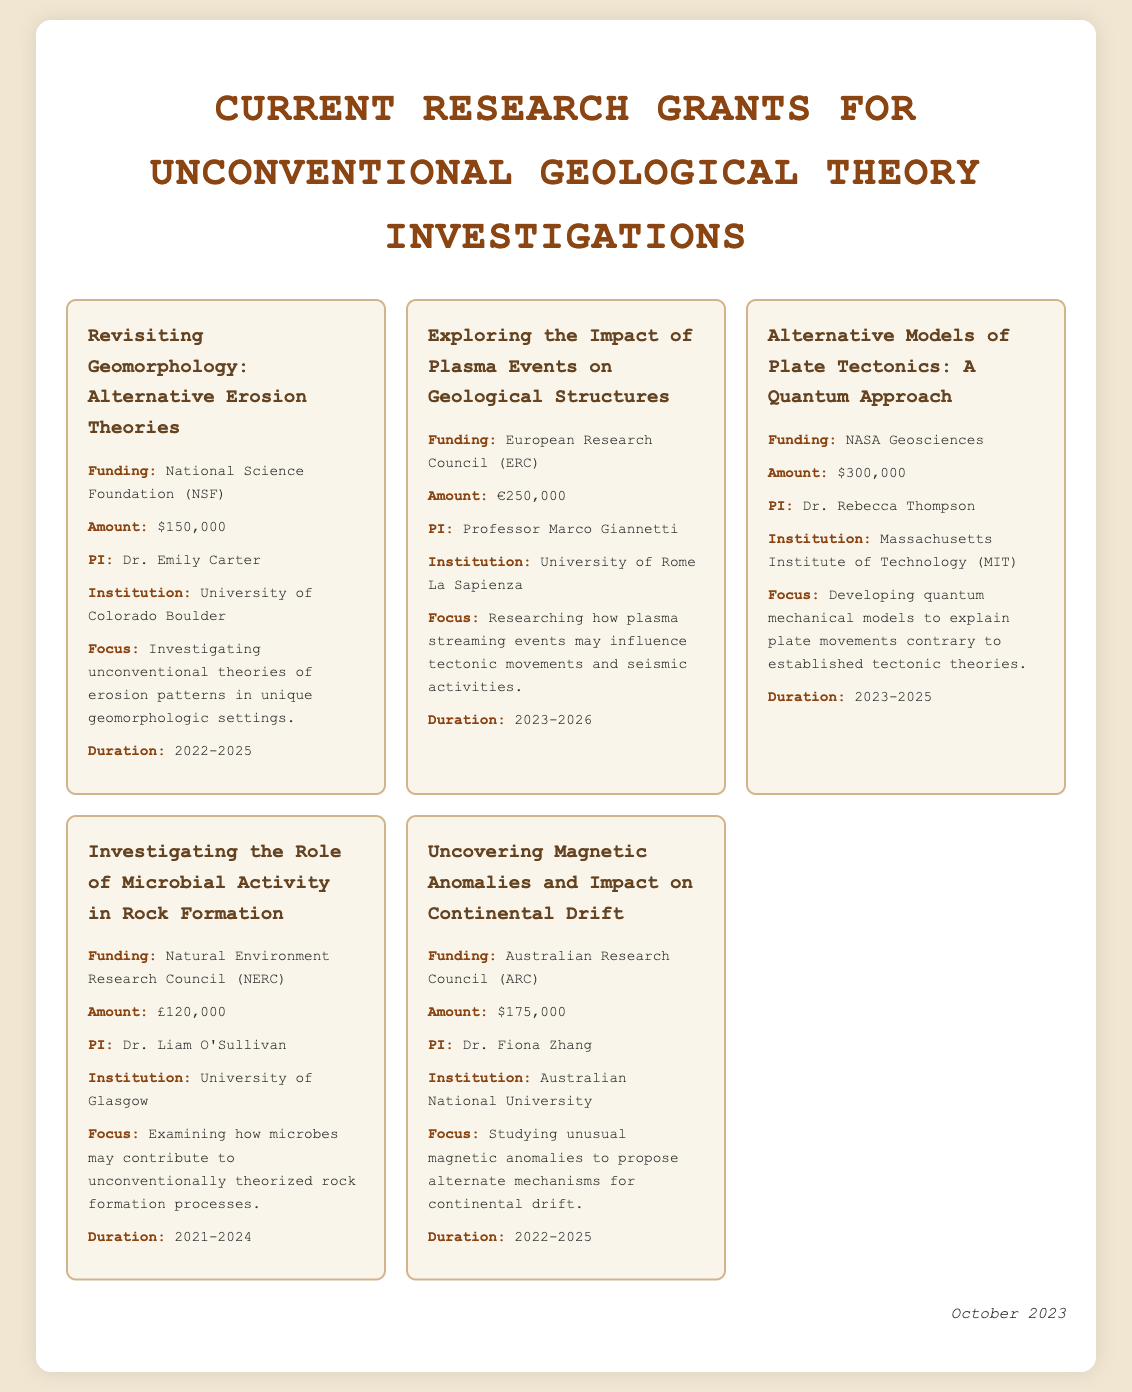What is the total funding amount for the grants listed? The total funding amount is the sum of all specified amounts in the document: $150,000 + €250,000 + $300,000 + £120,000 + $175,000, which translates to approximately $1,101,000 (considering conversions if needed).
Answer: Approximately $1,101,000 Who is the principal investigator for the grant on microbial activity? The principal investigator (PI) for that specific grant is mentioned clearly in the document, which is Dr. Liam O'Sullivan.
Answer: Dr. Liam O'Sullivan What is the duration of the grant focused on plasma events? The duration is stated clearly for each grant, and for the one focused on plasma events, it is from 2023 to 2026.
Answer: 2023-2026 Which institution is associated with the alternative models of plate tectonics grant? Each grant lists the associated institution, and for this grant, it is the Massachusetts Institute of Technology (MIT).
Answer: Massachusetts Institute of Technology (MIT) What unconventional aspect is being researched in the grant related to geomorphology? The focus for this grant outlines an investigation into unconventional theories of erosion patterns.
Answer: Unconventional theories of erosion patterns How much funding is associated with the grant investigating magnetic anomalies? The document specifies the funding associated with this grant clearly as $175,000.
Answer: $175,000 What is the geographic focus of the study led by Dr. Fiona Zhang? The focus area mentioned in the document is centered around studying unusual magnetic anomalies impacting continental drift, implying a geographic context.
Answer: Continental drift Which funding body supports the grant on quantum models of plate tectonics? The funding body is explicitly mentioned in the document, which is NASA Geosciences.
Answer: NASA Geosciences 